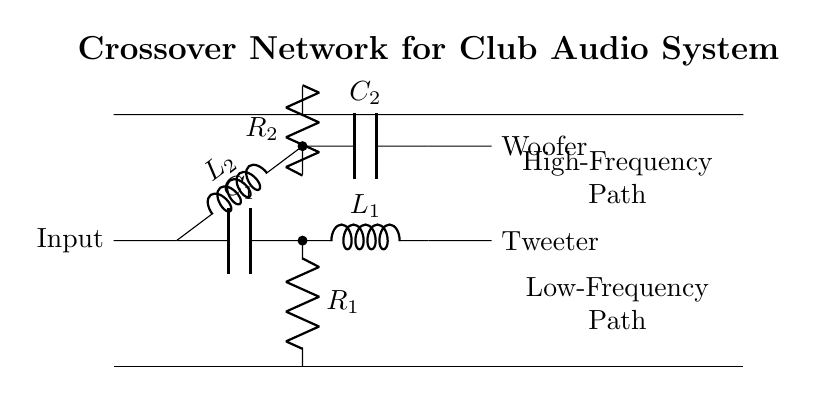What type of filters are used in this crossover network? The circuit contains a high-pass filter (composed of a capacitor and inductor) and a low-pass filter (composed of an inductor and capacitor). This is evident from the arrangement and labeling of components in the circuit diagram.
Answer: High-pass and low-pass What is the output component for high frequencies? The component labeled as tweeter is specifically designed to handle high frequencies, and it is connected to the high-frequency path in the circuit.
Answer: Tweeter What is the role of the resistor connected to the capacitor in the high-pass filter? The resistor labeled as R1 provides a path for the current and helps determine the cutoff frequency of the high-pass filter. Its placement parallel to the capacitor influences the filter’s performance by controlling the impedance at different frequencies.
Answer: Cutoff frequency How many inductors are present in the circuit? The circuit diagram shows two inductors labeled as L1 and L2. The inductors are integral to both the high-pass and low-pass filter sections of the circuit.
Answer: Two What is the total number of capacitors used in the crossover network? There are two capacitors in the crossover network, one for the high-pass filter (C1) and one for the low-pass filter (C2), as identified by their labels in the circuit diagram.
Answer: Two What is the purpose of the low-frequency path in the crossover network? The low-frequency path is designed to pass only lower frequency signals to the woofer while blocking higher frequency signals. This is typical in crossover networks to separate the sound frequencies for different types of speakers.
Answer: Pass lower frequencies 